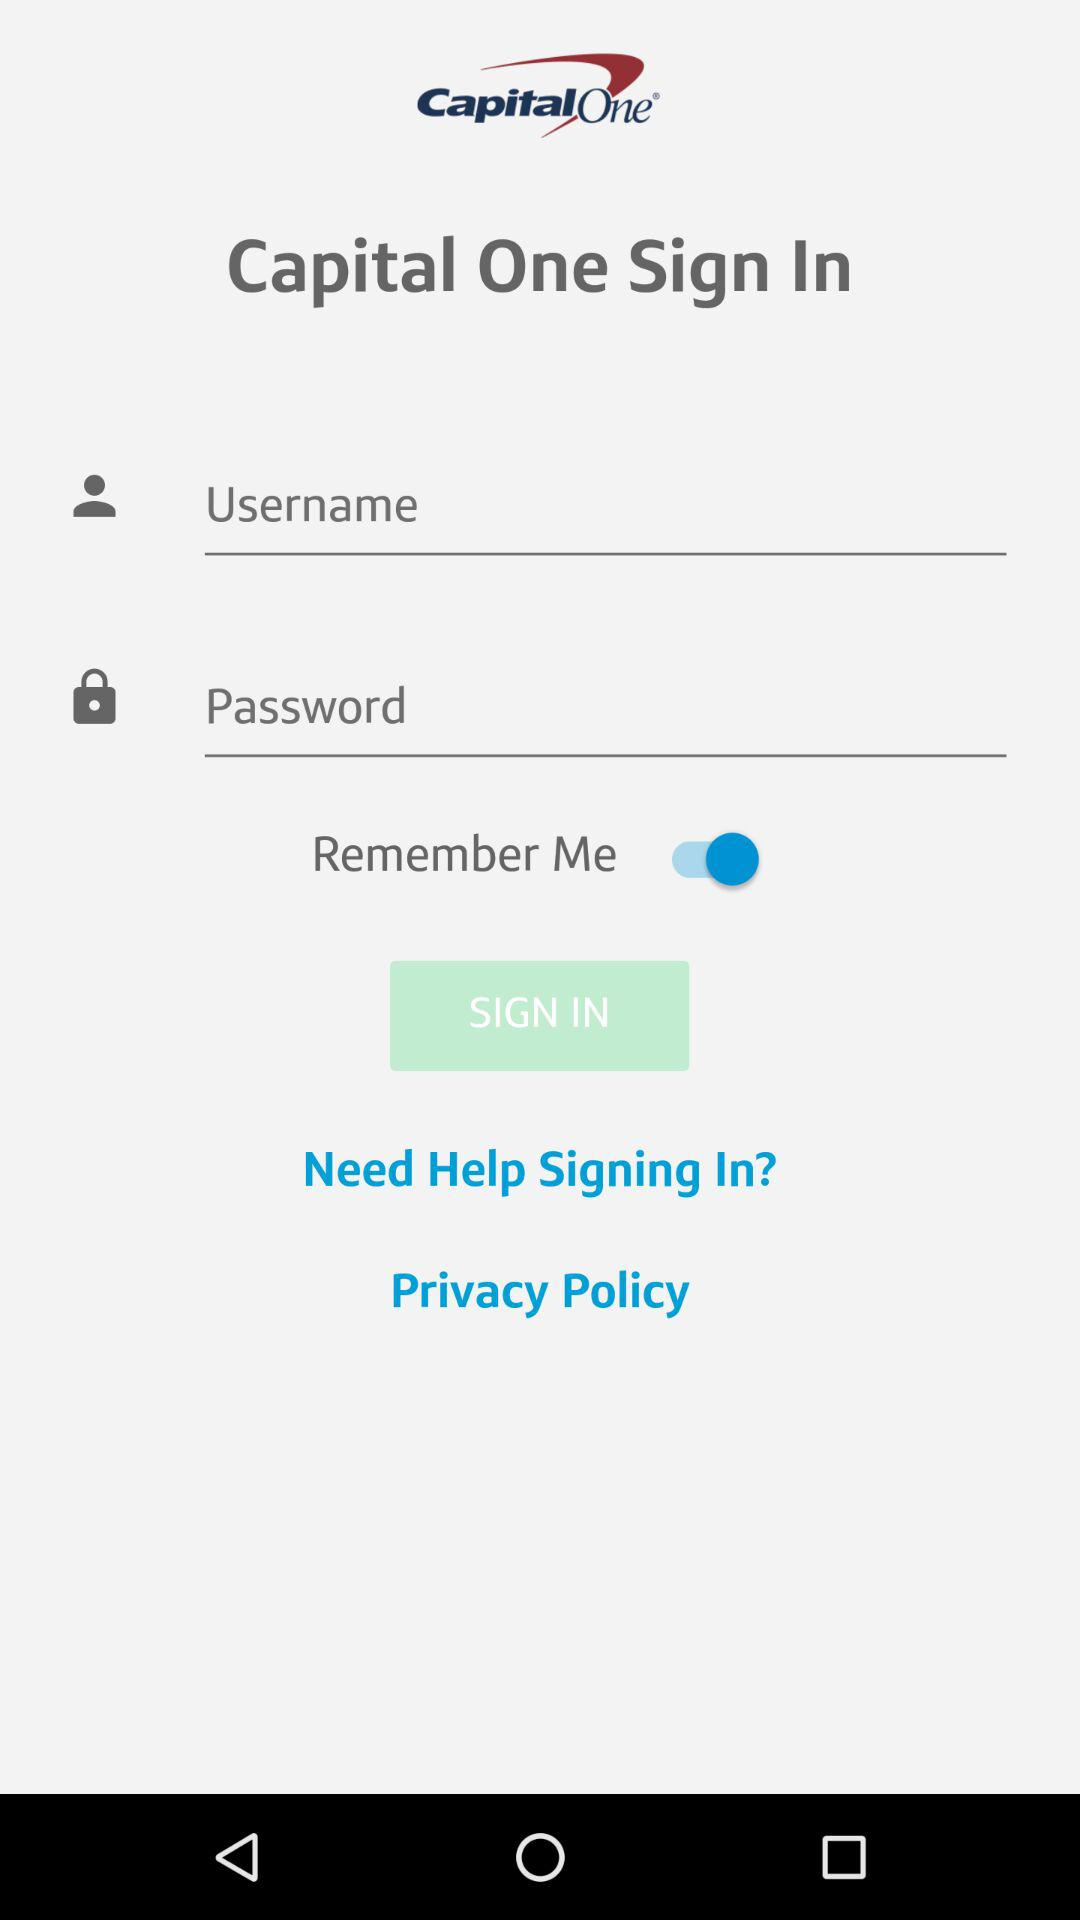What is the status of "Remember Me"? The status is "on". 